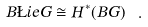<formula> <loc_0><loc_0><loc_500><loc_500>B \L i e G \cong H ^ { * } ( B G ) \ .</formula> 